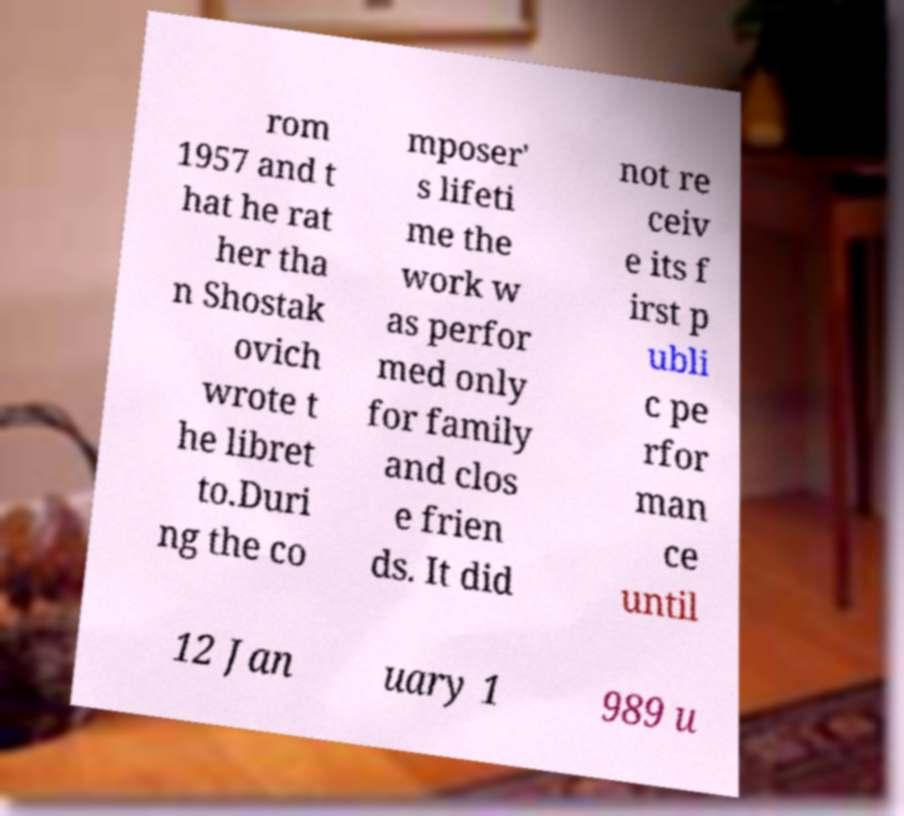There's text embedded in this image that I need extracted. Can you transcribe it verbatim? rom 1957 and t hat he rat her tha n Shostak ovich wrote t he libret to.Duri ng the co mposer' s lifeti me the work w as perfor med only for family and clos e frien ds. It did not re ceiv e its f irst p ubli c pe rfor man ce until 12 Jan uary 1 989 u 